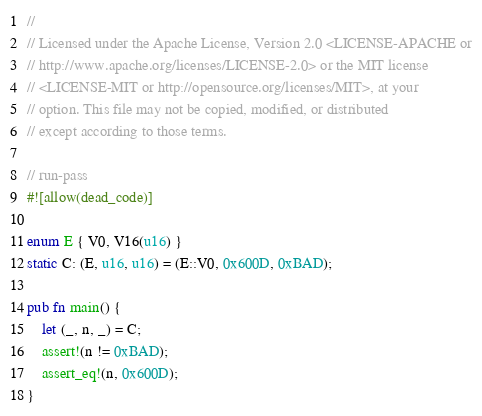<code> <loc_0><loc_0><loc_500><loc_500><_Rust_>//
// Licensed under the Apache License, Version 2.0 <LICENSE-APACHE or
// http://www.apache.org/licenses/LICENSE-2.0> or the MIT license
// <LICENSE-MIT or http://opensource.org/licenses/MIT>, at your
// option. This file may not be copied, modified, or distributed
// except according to those terms.

// run-pass
#![allow(dead_code)]

enum E { V0, V16(u16) }
static C: (E, u16, u16) = (E::V0, 0x600D, 0xBAD);

pub fn main() {
    let (_, n, _) = C;
    assert!(n != 0xBAD);
    assert_eq!(n, 0x600D);
}
</code> 